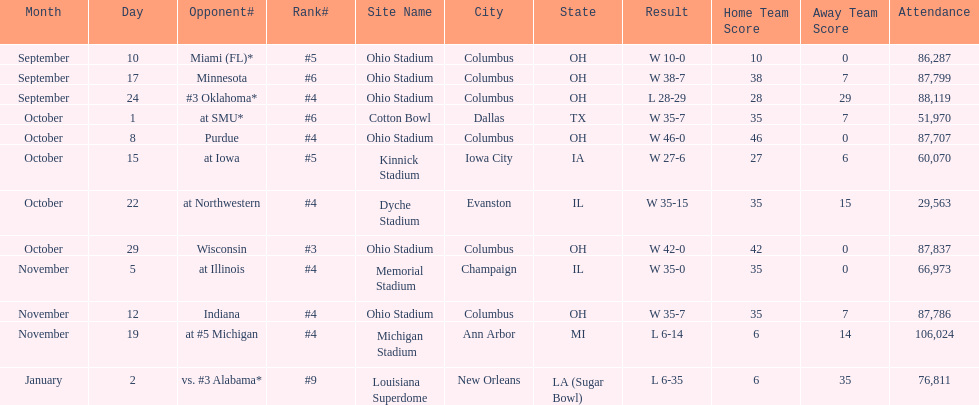How many dates are on the chart 12. 